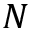<formula> <loc_0><loc_0><loc_500><loc_500>N</formula> 